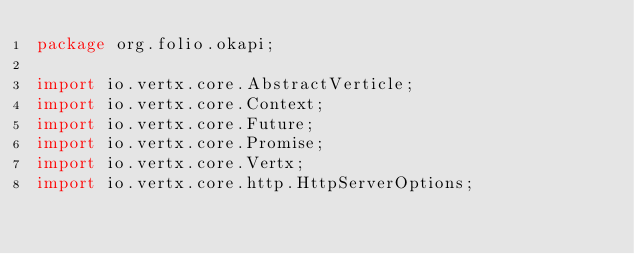Convert code to text. <code><loc_0><loc_0><loc_500><loc_500><_Java_>package org.folio.okapi;

import io.vertx.core.AbstractVerticle;
import io.vertx.core.Context;
import io.vertx.core.Future;
import io.vertx.core.Promise;
import io.vertx.core.Vertx;
import io.vertx.core.http.HttpServerOptions;</code> 